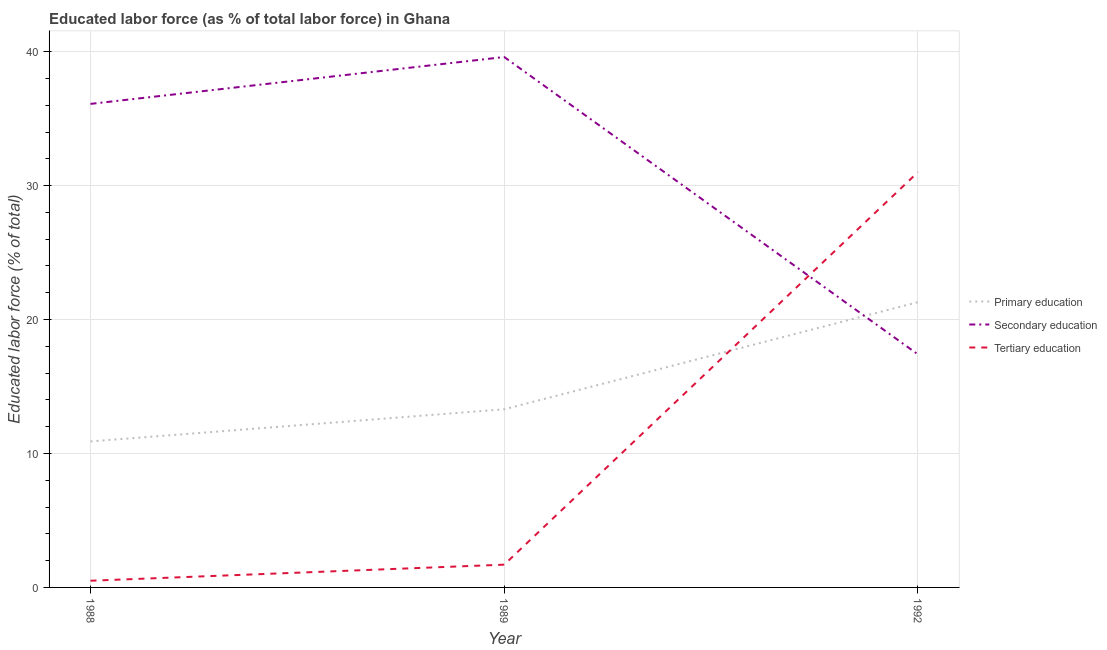What is the percentage of labor force who received secondary education in 1989?
Provide a short and direct response. 39.6. Across all years, what is the maximum percentage of labor force who received secondary education?
Give a very brief answer. 39.6. In which year was the percentage of labor force who received secondary education maximum?
Give a very brief answer. 1989. What is the total percentage of labor force who received primary education in the graph?
Your answer should be compact. 45.5. What is the difference between the percentage of labor force who received primary education in 1988 and that in 1989?
Offer a very short reply. -2.4. What is the difference between the percentage of labor force who received tertiary education in 1992 and the percentage of labor force who received secondary education in 1988?
Your answer should be compact. -5.1. What is the average percentage of labor force who received tertiary education per year?
Your response must be concise. 11.07. In the year 1988, what is the difference between the percentage of labor force who received primary education and percentage of labor force who received secondary education?
Your response must be concise. -25.2. In how many years, is the percentage of labor force who received secondary education greater than 36 %?
Your answer should be very brief. 2. What is the ratio of the percentage of labor force who received tertiary education in 1989 to that in 1992?
Provide a short and direct response. 0.05. Is the percentage of labor force who received tertiary education in 1988 less than that in 1989?
Ensure brevity in your answer.  Yes. Is the difference between the percentage of labor force who received secondary education in 1988 and 1992 greater than the difference between the percentage of labor force who received tertiary education in 1988 and 1992?
Provide a short and direct response. Yes. What is the difference between the highest and the second highest percentage of labor force who received secondary education?
Provide a short and direct response. 3.5. What is the difference between the highest and the lowest percentage of labor force who received secondary education?
Offer a very short reply. 22.2. Does the percentage of labor force who received tertiary education monotonically increase over the years?
Ensure brevity in your answer.  Yes. Is the percentage of labor force who received secondary education strictly greater than the percentage of labor force who received primary education over the years?
Provide a succinct answer. No. How many lines are there?
Offer a very short reply. 3. How many years are there in the graph?
Your response must be concise. 3. Are the values on the major ticks of Y-axis written in scientific E-notation?
Keep it short and to the point. No. Does the graph contain any zero values?
Give a very brief answer. No. Where does the legend appear in the graph?
Provide a succinct answer. Center right. How are the legend labels stacked?
Offer a very short reply. Vertical. What is the title of the graph?
Ensure brevity in your answer.  Educated labor force (as % of total labor force) in Ghana. Does "Negligence towards kids" appear as one of the legend labels in the graph?
Give a very brief answer. No. What is the label or title of the X-axis?
Your answer should be very brief. Year. What is the label or title of the Y-axis?
Offer a very short reply. Educated labor force (% of total). What is the Educated labor force (% of total) of Primary education in 1988?
Ensure brevity in your answer.  10.9. What is the Educated labor force (% of total) of Secondary education in 1988?
Ensure brevity in your answer.  36.1. What is the Educated labor force (% of total) of Tertiary education in 1988?
Your answer should be very brief. 0.5. What is the Educated labor force (% of total) in Primary education in 1989?
Your response must be concise. 13.3. What is the Educated labor force (% of total) in Secondary education in 1989?
Ensure brevity in your answer.  39.6. What is the Educated labor force (% of total) in Tertiary education in 1989?
Your response must be concise. 1.7. What is the Educated labor force (% of total) in Primary education in 1992?
Provide a succinct answer. 21.3. What is the Educated labor force (% of total) in Secondary education in 1992?
Your response must be concise. 17.4. Across all years, what is the maximum Educated labor force (% of total) in Primary education?
Keep it short and to the point. 21.3. Across all years, what is the maximum Educated labor force (% of total) of Secondary education?
Your answer should be compact. 39.6. Across all years, what is the maximum Educated labor force (% of total) in Tertiary education?
Your answer should be compact. 31. Across all years, what is the minimum Educated labor force (% of total) of Primary education?
Your response must be concise. 10.9. Across all years, what is the minimum Educated labor force (% of total) of Secondary education?
Your answer should be compact. 17.4. Across all years, what is the minimum Educated labor force (% of total) in Tertiary education?
Offer a terse response. 0.5. What is the total Educated labor force (% of total) of Primary education in the graph?
Provide a succinct answer. 45.5. What is the total Educated labor force (% of total) in Secondary education in the graph?
Ensure brevity in your answer.  93.1. What is the total Educated labor force (% of total) in Tertiary education in the graph?
Keep it short and to the point. 33.2. What is the difference between the Educated labor force (% of total) of Primary education in 1988 and that in 1992?
Your answer should be very brief. -10.4. What is the difference between the Educated labor force (% of total) in Tertiary education in 1988 and that in 1992?
Give a very brief answer. -30.5. What is the difference between the Educated labor force (% of total) of Tertiary education in 1989 and that in 1992?
Offer a terse response. -29.3. What is the difference between the Educated labor force (% of total) of Primary education in 1988 and the Educated labor force (% of total) of Secondary education in 1989?
Your response must be concise. -28.7. What is the difference between the Educated labor force (% of total) of Secondary education in 1988 and the Educated labor force (% of total) of Tertiary education in 1989?
Offer a terse response. 34.4. What is the difference between the Educated labor force (% of total) in Primary education in 1988 and the Educated labor force (% of total) in Tertiary education in 1992?
Keep it short and to the point. -20.1. What is the difference between the Educated labor force (% of total) in Secondary education in 1988 and the Educated labor force (% of total) in Tertiary education in 1992?
Provide a succinct answer. 5.1. What is the difference between the Educated labor force (% of total) in Primary education in 1989 and the Educated labor force (% of total) in Secondary education in 1992?
Provide a short and direct response. -4.1. What is the difference between the Educated labor force (% of total) in Primary education in 1989 and the Educated labor force (% of total) in Tertiary education in 1992?
Offer a terse response. -17.7. What is the average Educated labor force (% of total) in Primary education per year?
Provide a short and direct response. 15.17. What is the average Educated labor force (% of total) of Secondary education per year?
Provide a short and direct response. 31.03. What is the average Educated labor force (% of total) of Tertiary education per year?
Your response must be concise. 11.07. In the year 1988, what is the difference between the Educated labor force (% of total) of Primary education and Educated labor force (% of total) of Secondary education?
Keep it short and to the point. -25.2. In the year 1988, what is the difference between the Educated labor force (% of total) of Primary education and Educated labor force (% of total) of Tertiary education?
Give a very brief answer. 10.4. In the year 1988, what is the difference between the Educated labor force (% of total) in Secondary education and Educated labor force (% of total) in Tertiary education?
Make the answer very short. 35.6. In the year 1989, what is the difference between the Educated labor force (% of total) of Primary education and Educated labor force (% of total) of Secondary education?
Provide a short and direct response. -26.3. In the year 1989, what is the difference between the Educated labor force (% of total) in Secondary education and Educated labor force (% of total) in Tertiary education?
Offer a very short reply. 37.9. What is the ratio of the Educated labor force (% of total) of Primary education in 1988 to that in 1989?
Give a very brief answer. 0.82. What is the ratio of the Educated labor force (% of total) of Secondary education in 1988 to that in 1989?
Provide a short and direct response. 0.91. What is the ratio of the Educated labor force (% of total) in Tertiary education in 1988 to that in 1989?
Keep it short and to the point. 0.29. What is the ratio of the Educated labor force (% of total) of Primary education in 1988 to that in 1992?
Provide a short and direct response. 0.51. What is the ratio of the Educated labor force (% of total) of Secondary education in 1988 to that in 1992?
Your answer should be compact. 2.07. What is the ratio of the Educated labor force (% of total) of Tertiary education in 1988 to that in 1992?
Ensure brevity in your answer.  0.02. What is the ratio of the Educated labor force (% of total) of Primary education in 1989 to that in 1992?
Offer a very short reply. 0.62. What is the ratio of the Educated labor force (% of total) of Secondary education in 1989 to that in 1992?
Keep it short and to the point. 2.28. What is the ratio of the Educated labor force (% of total) of Tertiary education in 1989 to that in 1992?
Offer a terse response. 0.05. What is the difference between the highest and the second highest Educated labor force (% of total) of Secondary education?
Offer a very short reply. 3.5. What is the difference between the highest and the second highest Educated labor force (% of total) in Tertiary education?
Give a very brief answer. 29.3. What is the difference between the highest and the lowest Educated labor force (% of total) of Primary education?
Your answer should be very brief. 10.4. What is the difference between the highest and the lowest Educated labor force (% of total) in Tertiary education?
Provide a succinct answer. 30.5. 